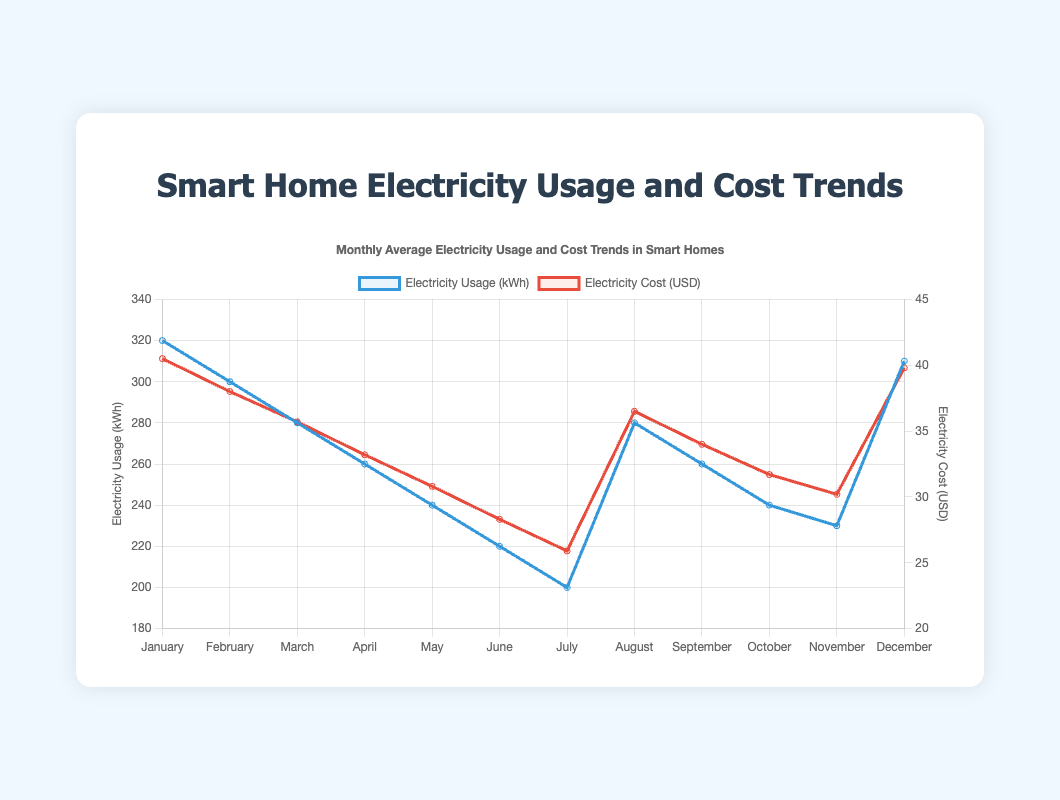What's the trend of Electricity Usage (kWh) from January to July? The trend of Electricity Usage from January to July is consistently decreasing. In January, the usage is 320 kWh, and it gradually drops each month to 200 kWh in July.
Answer: Decreasing In which month is the Electricity Cost highest? To determine the highest Electricity Cost, we look for the peak in the red line representing cost. The highest point is in January with a cost of 40.5 USD.
Answer: January By how many kWh does the Electricity Usage increase from July to August? The Electricity Usage in July is 200 kWh, and in August, it is 280 kWh. The increase can be calculated by subtracting the July value from the August value: 280 kWh - 200 kWh = 80 kWh.
Answer: 80 kWh Which month has the lowest Electricity Cost and what is that cost? The lowest Electricity Cost can be found by identifying the lowest point on the red line representing cost. This occurs in July with a cost of 25.9 USD.
Answer: July and 25.9 USD How does the Electricity Usage in October compare to that in November? Looking at the blue line, in October, the Electricity Usage is 240 kWh, and in November, it is 230 kWh. Comparing these values, the usage in October is higher than in November by 10 kWh.
Answer: October is higher by 10 kWh Is there any month where the Electricity Usage and Cost both increase compared to the previous month? We need to examine the lines for both Electricity Usage and Cost. From July to August, Electricity Usage increases from 200 kWh to 280 kWh, and Electricity Cost increases from 25.9 USD to 36.5 USD.
Answer: Yes, from July to August Calculate the average Electricity Usage (kWh) from March to May. The Electricity Usage from March, April, and May are 280 kWh, 260 kWh, and 240 kWh respectively. To find the average: (280 + 260 + 240) / 3 = 780 / 3 = 260 kWh.
Answer: 260 kWh Which month shows the greatest drop in Electricity Usage from the previous month? Comparing the monthly drops: January to February (320 - 300 = 20 kWh), February to March (300 - 280 = 20 kWh), March to April (280 - 260 = 20 kWh), April to May (260 - 240 = 20 kWh), and May to June (240 - 220 = 20 kWh), the biggest drop is from June to July (220 - 200 = 20 kWh). Therefore, the greatest drop of 20 kWh happens several times but the first significant drop is from June to July.
Answer: July What is the total Electricity Cost (USD) for the second half of the year (July - December)? Sum the Electricity Cost from July to December: 25.9 + 36.5 + 34.0 + 31.7 + 30.2 + 39.8 = 198.1 USD.
Answer: 198.1 USD 